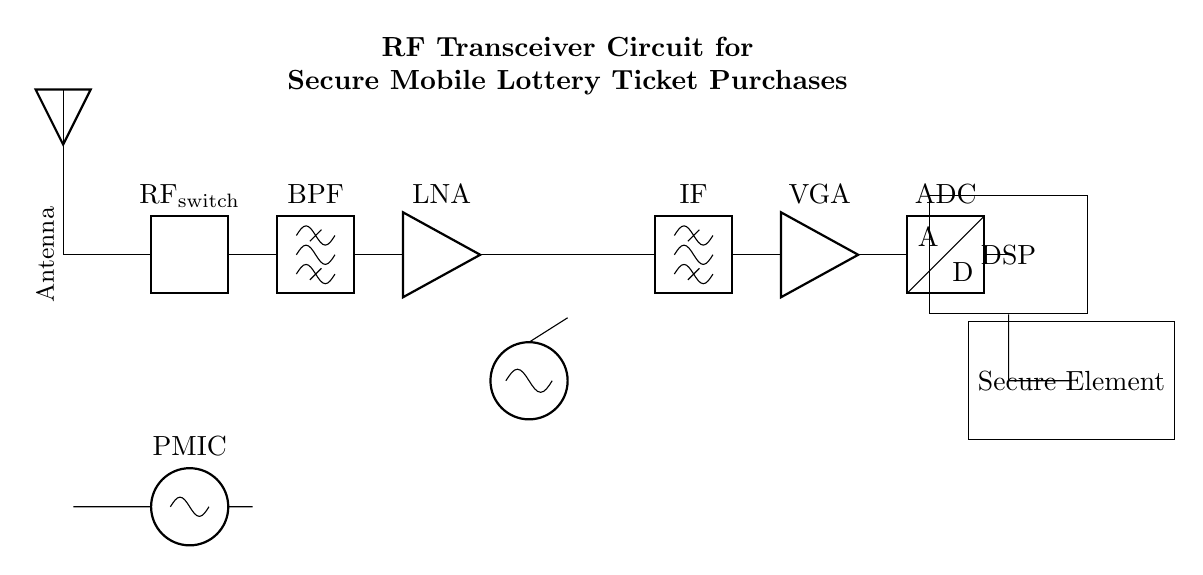What is the purpose of the RF switch? The RF switch is used to route the RF signal to the desired path, allowing for efficient signal management within the circuit.
Answer: Routing RF signal What component amplifies the signal after the bandpass filter? The Low Noise Amplifier (LNA) follows the bandpass filter to improve the signal strength while minimizing added noise.
Answer: Low Noise Amplifier How many main sections does the circuit have? The circuit can be divided into four main sections: RF Front End, Mixer and Local Oscillator, IF Stage, and Digital Baseband.
Answer: Four What is the function of the Secure Element? The Secure Element is responsible for securely processing and storing sensitive information, such as lottery ticket purchases, to ensure data integrity and security.
Answer: Secure processing What is the role of the Digital Signal Processor (DSP) in this circuit? The DSP processes the analog signals converted by the ADC into digital signals for further analysis and decision-making.
Answer: Signal processing What type of component is used for frequency control in this circuit? A Voltage-Controlled Oscillator (VCO) is used for frequency control, influencing the operation of the mixer and oscillator sections to define the transmitted and received frequencies.
Answer: Voltage-Controlled Oscillator 